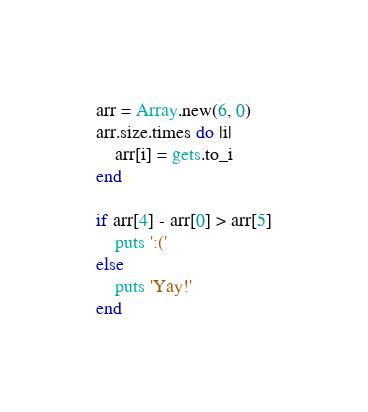Convert code to text. <code><loc_0><loc_0><loc_500><loc_500><_Ruby_>arr = Array.new(6, 0)
arr.size.times do |i|
	arr[i] = gets.to_i
end

if arr[4] - arr[0] > arr[5]
	puts ':('
else
	puts 'Yay!'
end</code> 